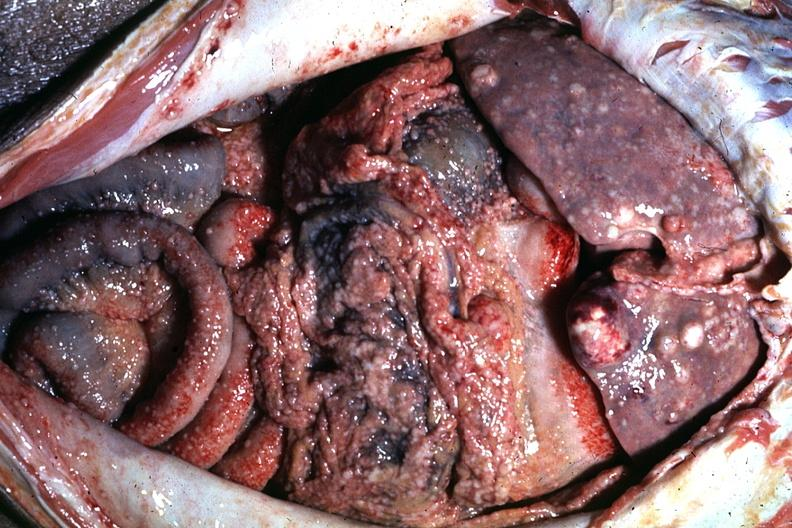s abdomen present?
Answer the question using a single word or phrase. Yes 